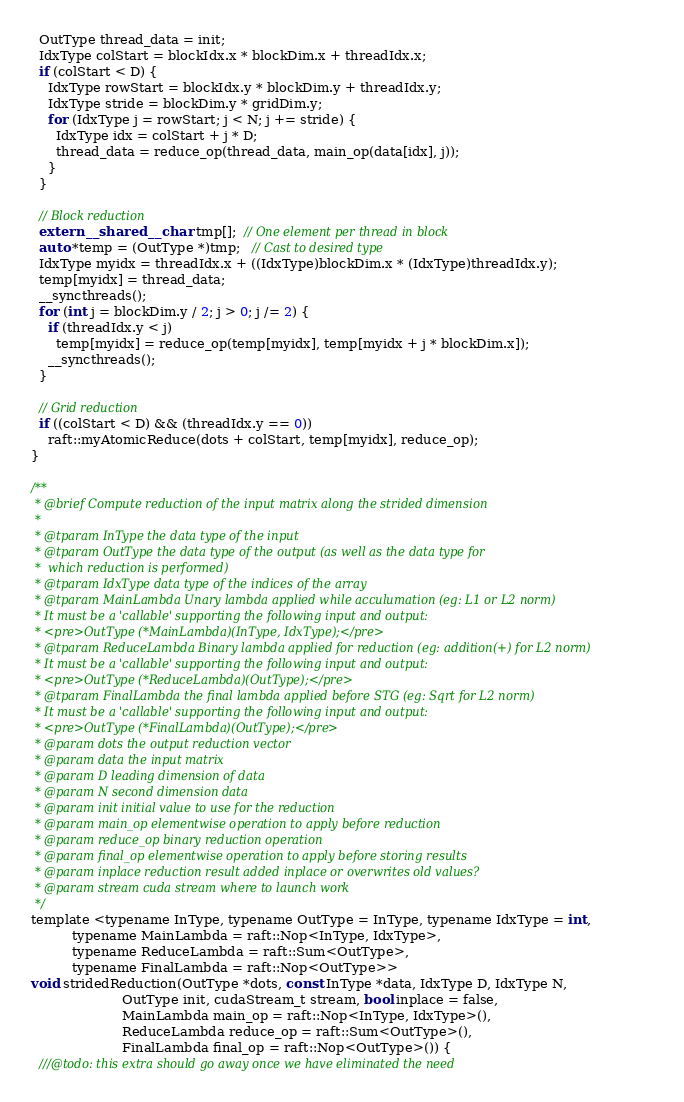<code> <loc_0><loc_0><loc_500><loc_500><_Cuda_>  OutType thread_data = init;
  IdxType colStart = blockIdx.x * blockDim.x + threadIdx.x;
  if (colStart < D) {
    IdxType rowStart = blockIdx.y * blockDim.y + threadIdx.y;
    IdxType stride = blockDim.y * gridDim.y;
    for (IdxType j = rowStart; j < N; j += stride) {
      IdxType idx = colStart + j * D;
      thread_data = reduce_op(thread_data, main_op(data[idx], j));
    }
  }

  // Block reduction
  extern __shared__ char tmp[];  // One element per thread in block
  auto *temp = (OutType *)tmp;   // Cast to desired type
  IdxType myidx = threadIdx.x + ((IdxType)blockDim.x * (IdxType)threadIdx.y);
  temp[myidx] = thread_data;
  __syncthreads();
  for (int j = blockDim.y / 2; j > 0; j /= 2) {
    if (threadIdx.y < j)
      temp[myidx] = reduce_op(temp[myidx], temp[myidx + j * blockDim.x]);
    __syncthreads();
  }

  // Grid reduction
  if ((colStart < D) && (threadIdx.y == 0))
    raft::myAtomicReduce(dots + colStart, temp[myidx], reduce_op);
}

/**
 * @brief Compute reduction of the input matrix along the strided dimension
 *
 * @tparam InType the data type of the input
 * @tparam OutType the data type of the output (as well as the data type for
 *  which reduction is performed)
 * @tparam IdxType data type of the indices of the array
 * @tparam MainLambda Unary lambda applied while acculumation (eg: L1 or L2 norm)
 * It must be a 'callable' supporting the following input and output:
 * <pre>OutType (*MainLambda)(InType, IdxType);</pre>
 * @tparam ReduceLambda Binary lambda applied for reduction (eg: addition(+) for L2 norm)
 * It must be a 'callable' supporting the following input and output:
 * <pre>OutType (*ReduceLambda)(OutType);</pre>
 * @tparam FinalLambda the final lambda applied before STG (eg: Sqrt for L2 norm)
 * It must be a 'callable' supporting the following input and output:
 * <pre>OutType (*FinalLambda)(OutType);</pre>
 * @param dots the output reduction vector
 * @param data the input matrix
 * @param D leading dimension of data
 * @param N second dimension data
 * @param init initial value to use for the reduction
 * @param main_op elementwise operation to apply before reduction
 * @param reduce_op binary reduction operation
 * @param final_op elementwise operation to apply before storing results
 * @param inplace reduction result added inplace or overwrites old values?
 * @param stream cuda stream where to launch work
 */
template <typename InType, typename OutType = InType, typename IdxType = int,
          typename MainLambda = raft::Nop<InType, IdxType>,
          typename ReduceLambda = raft::Sum<OutType>,
          typename FinalLambda = raft::Nop<OutType>>
void stridedReduction(OutType *dots, const InType *data, IdxType D, IdxType N,
                      OutType init, cudaStream_t stream, bool inplace = false,
                      MainLambda main_op = raft::Nop<InType, IdxType>(),
                      ReduceLambda reduce_op = raft::Sum<OutType>(),
                      FinalLambda final_op = raft::Nop<OutType>()) {
  ///@todo: this extra should go away once we have eliminated the need</code> 